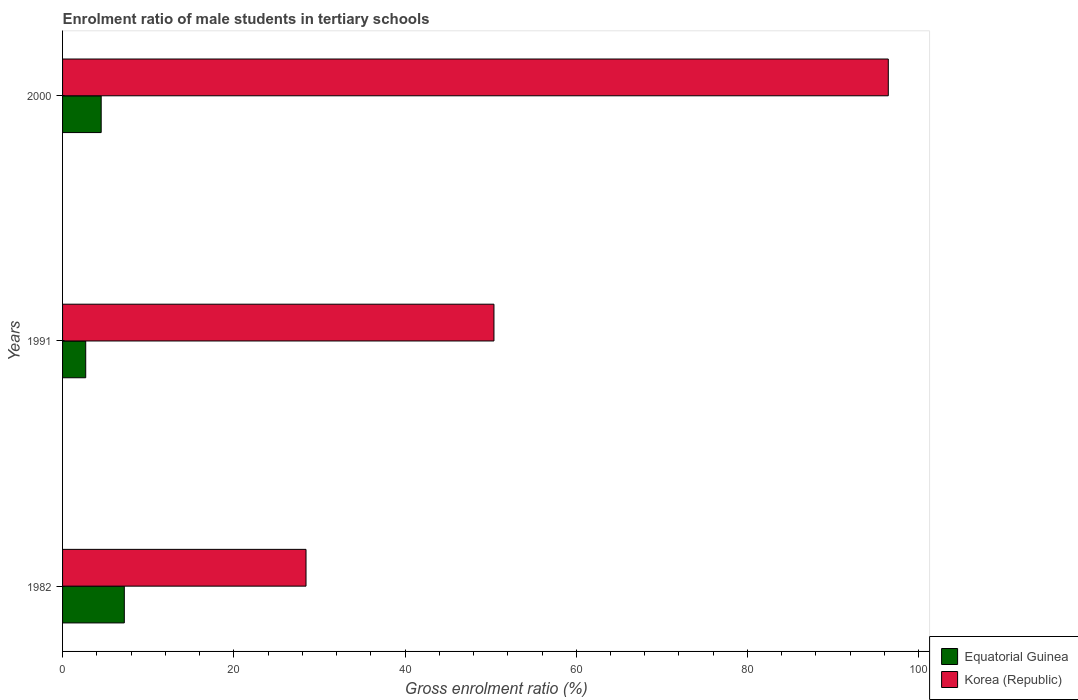Are the number of bars per tick equal to the number of legend labels?
Provide a succinct answer. Yes. Are the number of bars on each tick of the Y-axis equal?
Provide a succinct answer. Yes. What is the label of the 3rd group of bars from the top?
Offer a terse response. 1982. In how many cases, is the number of bars for a given year not equal to the number of legend labels?
Provide a short and direct response. 0. What is the enrolment ratio of male students in tertiary schools in Korea (Republic) in 1982?
Offer a very short reply. 28.44. Across all years, what is the maximum enrolment ratio of male students in tertiary schools in Equatorial Guinea?
Your response must be concise. 7.21. Across all years, what is the minimum enrolment ratio of male students in tertiary schools in Equatorial Guinea?
Offer a terse response. 2.7. In which year was the enrolment ratio of male students in tertiary schools in Korea (Republic) maximum?
Keep it short and to the point. 2000. In which year was the enrolment ratio of male students in tertiary schools in Equatorial Guinea minimum?
Keep it short and to the point. 1991. What is the total enrolment ratio of male students in tertiary schools in Korea (Republic) in the graph?
Keep it short and to the point. 175.27. What is the difference between the enrolment ratio of male students in tertiary schools in Equatorial Guinea in 1982 and that in 2000?
Provide a short and direct response. 2.7. What is the difference between the enrolment ratio of male students in tertiary schools in Equatorial Guinea in 2000 and the enrolment ratio of male students in tertiary schools in Korea (Republic) in 1982?
Your response must be concise. -23.93. What is the average enrolment ratio of male students in tertiary schools in Korea (Republic) per year?
Keep it short and to the point. 58.42. In the year 2000, what is the difference between the enrolment ratio of male students in tertiary schools in Equatorial Guinea and enrolment ratio of male students in tertiary schools in Korea (Republic)?
Keep it short and to the point. -91.94. In how many years, is the enrolment ratio of male students in tertiary schools in Equatorial Guinea greater than 8 %?
Ensure brevity in your answer.  0. What is the ratio of the enrolment ratio of male students in tertiary schools in Equatorial Guinea in 1991 to that in 2000?
Keep it short and to the point. 0.6. Is the enrolment ratio of male students in tertiary schools in Equatorial Guinea in 1982 less than that in 2000?
Offer a very short reply. No. Is the difference between the enrolment ratio of male students in tertiary schools in Equatorial Guinea in 1982 and 1991 greater than the difference between the enrolment ratio of male students in tertiary schools in Korea (Republic) in 1982 and 1991?
Your answer should be compact. Yes. What is the difference between the highest and the second highest enrolment ratio of male students in tertiary schools in Korea (Republic)?
Give a very brief answer. 46.06. What is the difference between the highest and the lowest enrolment ratio of male students in tertiary schools in Korea (Republic)?
Ensure brevity in your answer.  68.01. In how many years, is the enrolment ratio of male students in tertiary schools in Korea (Republic) greater than the average enrolment ratio of male students in tertiary schools in Korea (Republic) taken over all years?
Give a very brief answer. 1. Is the sum of the enrolment ratio of male students in tertiary schools in Korea (Republic) in 1982 and 2000 greater than the maximum enrolment ratio of male students in tertiary schools in Equatorial Guinea across all years?
Ensure brevity in your answer.  Yes. What does the 2nd bar from the top in 1991 represents?
Provide a short and direct response. Equatorial Guinea. Are all the bars in the graph horizontal?
Give a very brief answer. Yes. Are the values on the major ticks of X-axis written in scientific E-notation?
Your answer should be compact. No. Does the graph contain grids?
Your answer should be very brief. No. Where does the legend appear in the graph?
Your answer should be compact. Bottom right. How are the legend labels stacked?
Offer a terse response. Vertical. What is the title of the graph?
Make the answer very short. Enrolment ratio of male students in tertiary schools. What is the label or title of the X-axis?
Give a very brief answer. Gross enrolment ratio (%). What is the label or title of the Y-axis?
Your answer should be very brief. Years. What is the Gross enrolment ratio (%) in Equatorial Guinea in 1982?
Provide a short and direct response. 7.21. What is the Gross enrolment ratio (%) of Korea (Republic) in 1982?
Your response must be concise. 28.44. What is the Gross enrolment ratio (%) of Equatorial Guinea in 1991?
Offer a terse response. 2.7. What is the Gross enrolment ratio (%) in Korea (Republic) in 1991?
Provide a succinct answer. 50.39. What is the Gross enrolment ratio (%) in Equatorial Guinea in 2000?
Offer a very short reply. 4.51. What is the Gross enrolment ratio (%) of Korea (Republic) in 2000?
Provide a short and direct response. 96.45. Across all years, what is the maximum Gross enrolment ratio (%) of Equatorial Guinea?
Provide a short and direct response. 7.21. Across all years, what is the maximum Gross enrolment ratio (%) in Korea (Republic)?
Offer a very short reply. 96.45. Across all years, what is the minimum Gross enrolment ratio (%) of Equatorial Guinea?
Offer a very short reply. 2.7. Across all years, what is the minimum Gross enrolment ratio (%) of Korea (Republic)?
Your answer should be compact. 28.44. What is the total Gross enrolment ratio (%) of Equatorial Guinea in the graph?
Your answer should be very brief. 14.43. What is the total Gross enrolment ratio (%) in Korea (Republic) in the graph?
Give a very brief answer. 175.27. What is the difference between the Gross enrolment ratio (%) of Equatorial Guinea in 1982 and that in 1991?
Make the answer very short. 4.51. What is the difference between the Gross enrolment ratio (%) of Korea (Republic) in 1982 and that in 1991?
Keep it short and to the point. -21.95. What is the difference between the Gross enrolment ratio (%) of Equatorial Guinea in 1982 and that in 2000?
Make the answer very short. 2.7. What is the difference between the Gross enrolment ratio (%) of Korea (Republic) in 1982 and that in 2000?
Provide a short and direct response. -68.01. What is the difference between the Gross enrolment ratio (%) in Equatorial Guinea in 1991 and that in 2000?
Your response must be concise. -1.81. What is the difference between the Gross enrolment ratio (%) of Korea (Republic) in 1991 and that in 2000?
Provide a short and direct response. -46.06. What is the difference between the Gross enrolment ratio (%) of Equatorial Guinea in 1982 and the Gross enrolment ratio (%) of Korea (Republic) in 1991?
Your response must be concise. -43.17. What is the difference between the Gross enrolment ratio (%) of Equatorial Guinea in 1982 and the Gross enrolment ratio (%) of Korea (Republic) in 2000?
Your answer should be compact. -89.23. What is the difference between the Gross enrolment ratio (%) in Equatorial Guinea in 1991 and the Gross enrolment ratio (%) in Korea (Republic) in 2000?
Keep it short and to the point. -93.74. What is the average Gross enrolment ratio (%) of Equatorial Guinea per year?
Provide a succinct answer. 4.81. What is the average Gross enrolment ratio (%) of Korea (Republic) per year?
Provide a succinct answer. 58.42. In the year 1982, what is the difference between the Gross enrolment ratio (%) in Equatorial Guinea and Gross enrolment ratio (%) in Korea (Republic)?
Make the answer very short. -21.22. In the year 1991, what is the difference between the Gross enrolment ratio (%) of Equatorial Guinea and Gross enrolment ratio (%) of Korea (Republic)?
Give a very brief answer. -47.68. In the year 2000, what is the difference between the Gross enrolment ratio (%) of Equatorial Guinea and Gross enrolment ratio (%) of Korea (Republic)?
Provide a short and direct response. -91.94. What is the ratio of the Gross enrolment ratio (%) of Equatorial Guinea in 1982 to that in 1991?
Provide a succinct answer. 2.67. What is the ratio of the Gross enrolment ratio (%) of Korea (Republic) in 1982 to that in 1991?
Make the answer very short. 0.56. What is the ratio of the Gross enrolment ratio (%) of Equatorial Guinea in 1982 to that in 2000?
Offer a terse response. 1.6. What is the ratio of the Gross enrolment ratio (%) of Korea (Republic) in 1982 to that in 2000?
Ensure brevity in your answer.  0.29. What is the ratio of the Gross enrolment ratio (%) of Equatorial Guinea in 1991 to that in 2000?
Offer a very short reply. 0.6. What is the ratio of the Gross enrolment ratio (%) in Korea (Republic) in 1991 to that in 2000?
Offer a terse response. 0.52. What is the difference between the highest and the second highest Gross enrolment ratio (%) of Equatorial Guinea?
Your answer should be compact. 2.7. What is the difference between the highest and the second highest Gross enrolment ratio (%) in Korea (Republic)?
Your answer should be very brief. 46.06. What is the difference between the highest and the lowest Gross enrolment ratio (%) in Equatorial Guinea?
Offer a terse response. 4.51. What is the difference between the highest and the lowest Gross enrolment ratio (%) of Korea (Republic)?
Your answer should be compact. 68.01. 